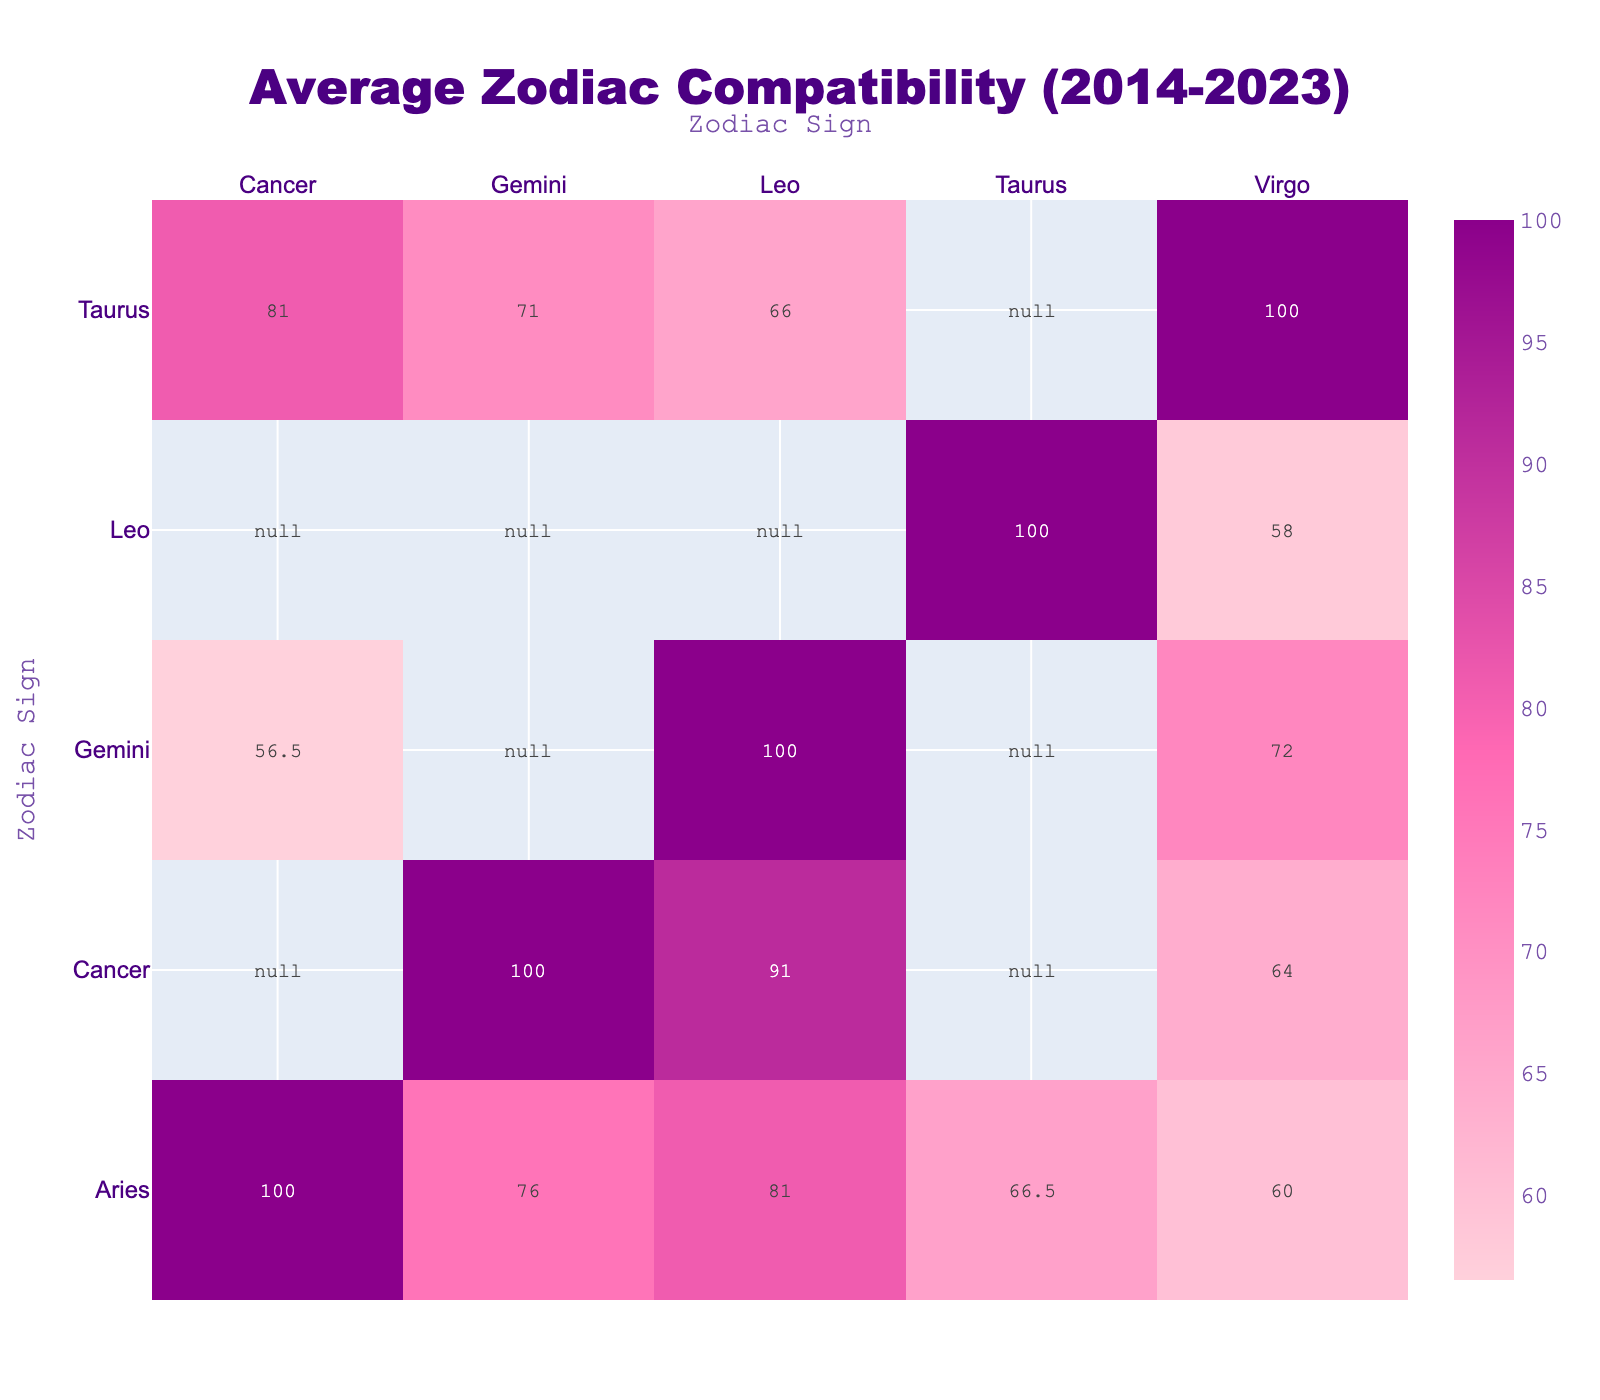What is the compatibility rating between Aries and Leo for the year 2023? The table shows the specific compatibility rating between Aries and Leo for 2023, which is directly listed. According to the table, the rating is 82.
Answer: 82 Which zodiac sign has the highest compatibility rating with Cancer in 2023? To find this, we can look at all the compatibility ratings for Cancer in 2023 and identify the highest one. For 2023, the ratings for Cancer are 52 (Aries), 82 (Taurus), 58 (Gemini), and 92 (Leo). The highest compatibility rating is 92, which is with Leo.
Answer: Leo What is the average compatibility rating of Taurus with all other signs for the year 2023? We consider the compatibility ratings of Taurus with each sign for 2023. The ratings are as follows: Aries (68), Gemini (72), Cancer (82), and Leo (67). We sum these ratings: 68 + 72 + 82 + 67 = 289, and since there are 4 ratings, we find the average by dividing: 289 / 4 = 72.25.
Answer: 72.25 Is the compatibility rating between Gemini and Virgo higher in 2023 than in 2014? We compare the compatibility ratings from both years: Gemini and Virgo had a rating of 72 in 2014 and 72 in 2023. Since both values are equal, we conclude that the statement is false; they are not higher in 2023.
Answer: No What is the difference in the compatibility rating between Cancer and Leo in 2023 and 2014? First, we find the ratings for both years: for 2014, the compatibility rating is 90, and for 2023, it is 92. The difference is calculated as 92 - 90 = 2.
Answer: 2 What was the average compatibility rating for Aries with Taurus and Gemini in 2014? To find this, we look at the ratings: Aries and Taurus had a rating of 65, and Aries and Gemini had a rating of 75. The average is calculated by summing these ratings: 65 + 75 = 140, then dividing by the number of ratings (2): 140 / 2 = 70.
Answer: 70 Do Aries and Virgo have a compatibility rating higher than 60 in 2023? Checking their 2023 compatibility, we see the rating is 60. Since it is not higher than 60, the answer is no.
Answer: No Is the compatibility rating of any pair lower than 50 in 2014? We examine the table entries from 2014. The ratings listed are: 65, 75, 50, 80, 60, 70, 80, 65, 85, 55, 68, 72, 90, 64, and 58. Among these, the lowest is 50. Therefore, there are ratings lower than 50, and the answer is affirmative.
Answer: Yes 